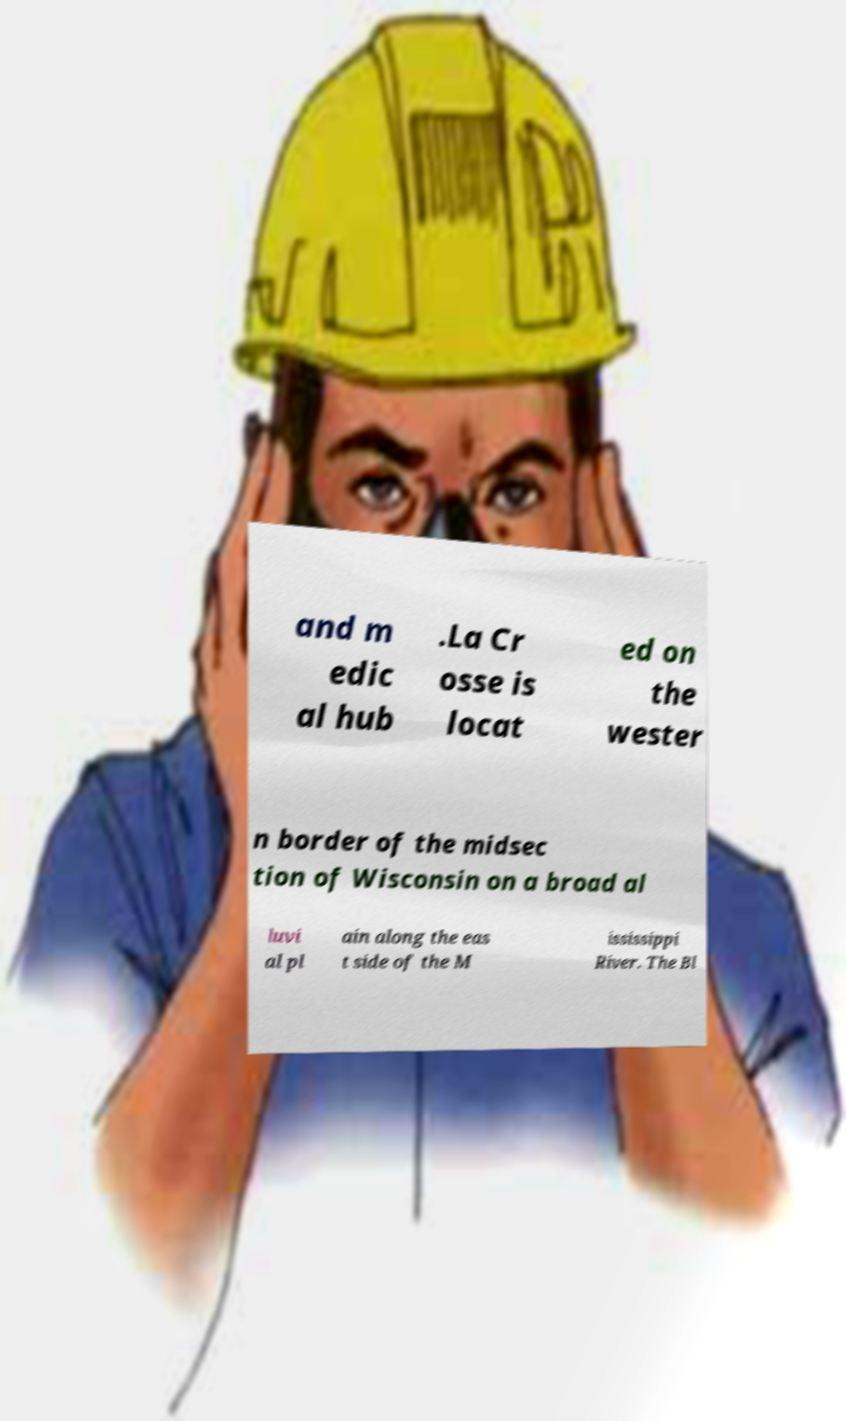Could you assist in decoding the text presented in this image and type it out clearly? and m edic al hub .La Cr osse is locat ed on the wester n border of the midsec tion of Wisconsin on a broad al luvi al pl ain along the eas t side of the M ississippi River. The Bl 